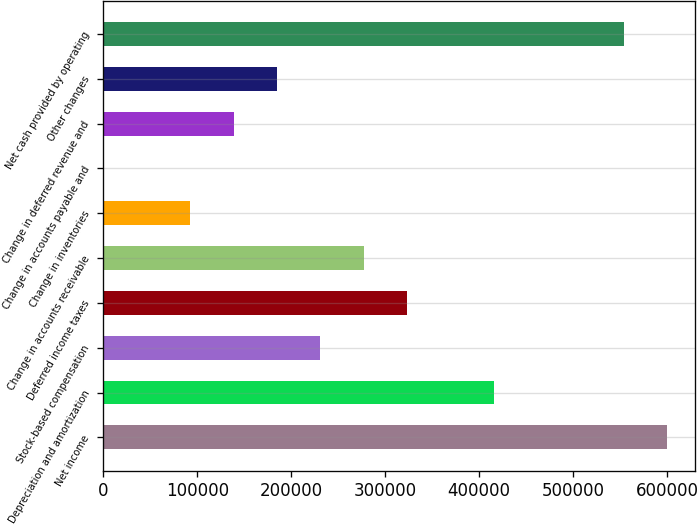<chart> <loc_0><loc_0><loc_500><loc_500><bar_chart><fcel>Net income<fcel>Depreciation and amortization<fcel>Stock-based compensation<fcel>Deferred income taxes<fcel>Change in accounts receivable<fcel>Change in inventories<fcel>Change in accounts payable and<fcel>Change in deferred revenue and<fcel>Other changes<fcel>Net cash provided by operating<nl><fcel>599707<fcel>415355<fcel>231003<fcel>323179<fcel>277091<fcel>92739<fcel>563<fcel>138827<fcel>184915<fcel>553619<nl></chart> 